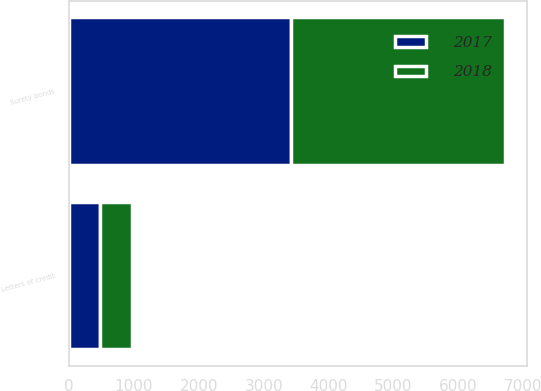Convert chart to OTSL. <chart><loc_0><loc_0><loc_500><loc_500><stacked_bar_chart><ecel><fcel>Letters of credit<fcel>Surety bonds<nl><fcel>2017<fcel>474.2<fcel>3418.5<nl><fcel>2018<fcel>490.3<fcel>3307.3<nl></chart> 